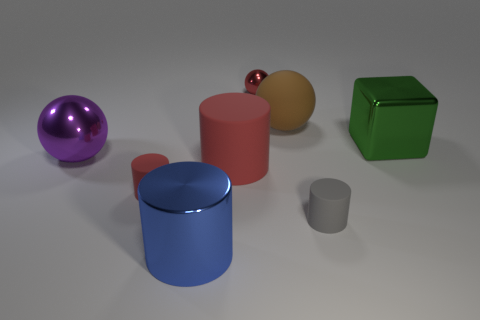What number of other tiny shiny things are the same shape as the purple thing?
Ensure brevity in your answer.  1. There is a thing that is both behind the green metal object and on the right side of the tiny red sphere; what is its material?
Your answer should be very brief. Rubber. There is a purple thing; what number of big green metallic things are in front of it?
Provide a succinct answer. 0. How many big cyan metal blocks are there?
Provide a short and direct response. 0. Does the green object have the same size as the gray thing?
Give a very brief answer. No. There is a rubber cylinder that is to the left of the large metal cylinder that is in front of the green shiny block; is there a big metal cylinder that is left of it?
Offer a very short reply. No. What material is the tiny object that is the same shape as the big brown thing?
Provide a succinct answer. Metal. There is a large matte object behind the large purple ball; what is its color?
Provide a short and direct response. Brown. The brown thing is what size?
Offer a terse response. Large. Does the purple shiny ball have the same size as the cylinder that is on the right side of the red metallic object?
Offer a very short reply. No. 